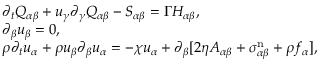Convert formula to latex. <formula><loc_0><loc_0><loc_500><loc_500>\begin{array} { r l } & { \partial _ { t } Q _ { \alpha \beta } + u _ { \gamma } \partial _ { \gamma } Q _ { \alpha \beta } - S _ { \alpha \beta } = \Gamma H _ { \alpha \beta } , } \\ & { \partial _ { \beta } u _ { \beta } = 0 , } \\ & { \rho \partial _ { t } u _ { \alpha } + \rho u _ { \beta } \partial _ { \beta } u _ { \alpha } = - \chi u _ { \alpha } + \partial _ { \beta } [ 2 \eta A _ { \alpha \beta } + \sigma _ { \alpha \beta } ^ { n } + \rho f _ { \alpha } ] , } \end{array}</formula> 